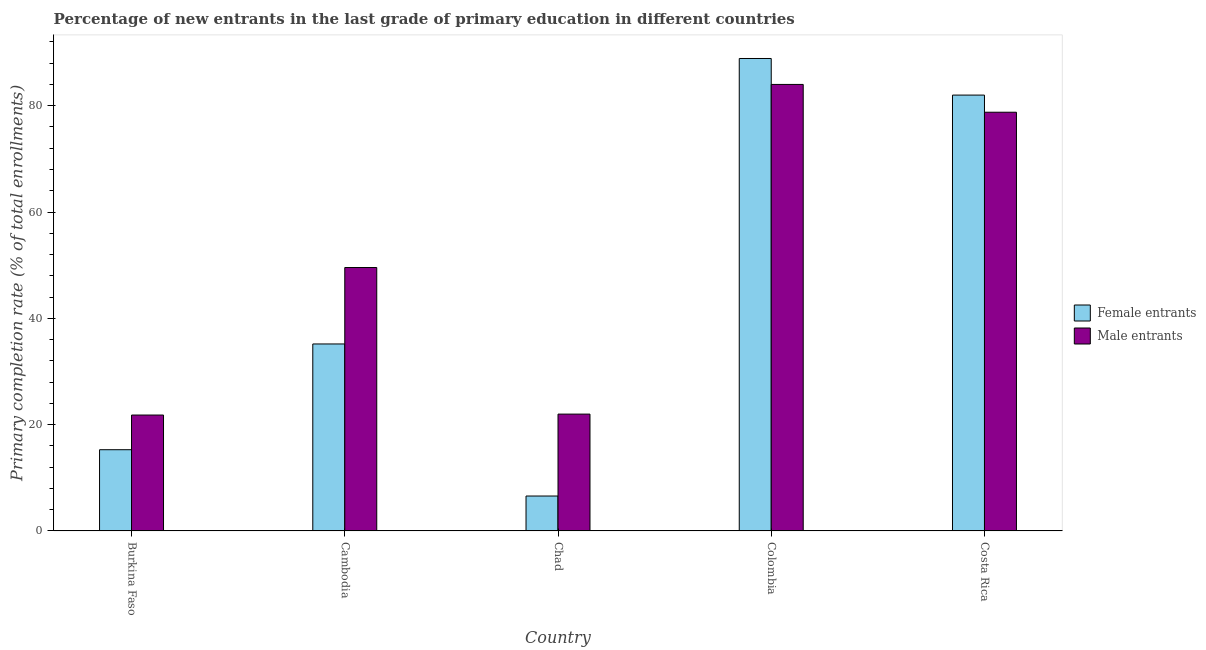How many different coloured bars are there?
Provide a short and direct response. 2. How many bars are there on the 2nd tick from the left?
Offer a terse response. 2. What is the label of the 3rd group of bars from the left?
Ensure brevity in your answer.  Chad. What is the primary completion rate of male entrants in Burkina Faso?
Keep it short and to the point. 21.8. Across all countries, what is the maximum primary completion rate of male entrants?
Offer a very short reply. 84. Across all countries, what is the minimum primary completion rate of female entrants?
Provide a succinct answer. 6.57. In which country was the primary completion rate of male entrants minimum?
Offer a terse response. Burkina Faso. What is the total primary completion rate of female entrants in the graph?
Your answer should be compact. 227.9. What is the difference between the primary completion rate of female entrants in Burkina Faso and that in Colombia?
Your answer should be very brief. -73.6. What is the difference between the primary completion rate of male entrants in Cambodia and the primary completion rate of female entrants in Chad?
Keep it short and to the point. 42.99. What is the average primary completion rate of female entrants per country?
Give a very brief answer. 45.58. What is the difference between the primary completion rate of male entrants and primary completion rate of female entrants in Costa Rica?
Provide a short and direct response. -3.22. What is the ratio of the primary completion rate of male entrants in Burkina Faso to that in Costa Rica?
Your answer should be very brief. 0.28. Is the difference between the primary completion rate of female entrants in Chad and Costa Rica greater than the difference between the primary completion rate of male entrants in Chad and Costa Rica?
Give a very brief answer. No. What is the difference between the highest and the second highest primary completion rate of female entrants?
Your response must be concise. 6.88. What is the difference between the highest and the lowest primary completion rate of female entrants?
Your response must be concise. 82.31. In how many countries, is the primary completion rate of male entrants greater than the average primary completion rate of male entrants taken over all countries?
Provide a short and direct response. 2. What does the 1st bar from the left in Colombia represents?
Make the answer very short. Female entrants. What does the 1st bar from the right in Chad represents?
Ensure brevity in your answer.  Male entrants. How many bars are there?
Make the answer very short. 10. How many countries are there in the graph?
Give a very brief answer. 5. Does the graph contain any zero values?
Provide a succinct answer. No. Where does the legend appear in the graph?
Ensure brevity in your answer.  Center right. How are the legend labels stacked?
Ensure brevity in your answer.  Vertical. What is the title of the graph?
Provide a succinct answer. Percentage of new entrants in the last grade of primary education in different countries. What is the label or title of the X-axis?
Ensure brevity in your answer.  Country. What is the label or title of the Y-axis?
Keep it short and to the point. Primary completion rate (% of total enrollments). What is the Primary completion rate (% of total enrollments) in Female entrants in Burkina Faso?
Make the answer very short. 15.28. What is the Primary completion rate (% of total enrollments) in Male entrants in Burkina Faso?
Your answer should be very brief. 21.8. What is the Primary completion rate (% of total enrollments) in Female entrants in Cambodia?
Your response must be concise. 35.18. What is the Primary completion rate (% of total enrollments) in Male entrants in Cambodia?
Make the answer very short. 49.56. What is the Primary completion rate (% of total enrollments) in Female entrants in Chad?
Keep it short and to the point. 6.57. What is the Primary completion rate (% of total enrollments) of Male entrants in Chad?
Your answer should be very brief. 21.98. What is the Primary completion rate (% of total enrollments) of Female entrants in Colombia?
Your answer should be compact. 88.88. What is the Primary completion rate (% of total enrollments) in Male entrants in Colombia?
Your response must be concise. 84. What is the Primary completion rate (% of total enrollments) of Female entrants in Costa Rica?
Ensure brevity in your answer.  82. What is the Primary completion rate (% of total enrollments) of Male entrants in Costa Rica?
Your answer should be very brief. 78.77. Across all countries, what is the maximum Primary completion rate (% of total enrollments) of Female entrants?
Offer a very short reply. 88.88. Across all countries, what is the maximum Primary completion rate (% of total enrollments) in Male entrants?
Provide a short and direct response. 84. Across all countries, what is the minimum Primary completion rate (% of total enrollments) in Female entrants?
Offer a very short reply. 6.57. Across all countries, what is the minimum Primary completion rate (% of total enrollments) of Male entrants?
Make the answer very short. 21.8. What is the total Primary completion rate (% of total enrollments) of Female entrants in the graph?
Ensure brevity in your answer.  227.9. What is the total Primary completion rate (% of total enrollments) of Male entrants in the graph?
Offer a terse response. 256.11. What is the difference between the Primary completion rate (% of total enrollments) in Female entrants in Burkina Faso and that in Cambodia?
Make the answer very short. -19.89. What is the difference between the Primary completion rate (% of total enrollments) in Male entrants in Burkina Faso and that in Cambodia?
Provide a short and direct response. -27.75. What is the difference between the Primary completion rate (% of total enrollments) of Female entrants in Burkina Faso and that in Chad?
Provide a short and direct response. 8.71. What is the difference between the Primary completion rate (% of total enrollments) of Male entrants in Burkina Faso and that in Chad?
Give a very brief answer. -0.18. What is the difference between the Primary completion rate (% of total enrollments) of Female entrants in Burkina Faso and that in Colombia?
Give a very brief answer. -73.6. What is the difference between the Primary completion rate (% of total enrollments) of Male entrants in Burkina Faso and that in Colombia?
Your answer should be compact. -62.2. What is the difference between the Primary completion rate (% of total enrollments) of Female entrants in Burkina Faso and that in Costa Rica?
Provide a short and direct response. -66.71. What is the difference between the Primary completion rate (% of total enrollments) of Male entrants in Burkina Faso and that in Costa Rica?
Give a very brief answer. -56.97. What is the difference between the Primary completion rate (% of total enrollments) in Female entrants in Cambodia and that in Chad?
Provide a succinct answer. 28.61. What is the difference between the Primary completion rate (% of total enrollments) in Male entrants in Cambodia and that in Chad?
Provide a short and direct response. 27.58. What is the difference between the Primary completion rate (% of total enrollments) of Female entrants in Cambodia and that in Colombia?
Your answer should be very brief. -53.7. What is the difference between the Primary completion rate (% of total enrollments) of Male entrants in Cambodia and that in Colombia?
Your answer should be very brief. -34.44. What is the difference between the Primary completion rate (% of total enrollments) in Female entrants in Cambodia and that in Costa Rica?
Make the answer very short. -46.82. What is the difference between the Primary completion rate (% of total enrollments) in Male entrants in Cambodia and that in Costa Rica?
Your response must be concise. -29.22. What is the difference between the Primary completion rate (% of total enrollments) in Female entrants in Chad and that in Colombia?
Make the answer very short. -82.31. What is the difference between the Primary completion rate (% of total enrollments) of Male entrants in Chad and that in Colombia?
Make the answer very short. -62.02. What is the difference between the Primary completion rate (% of total enrollments) in Female entrants in Chad and that in Costa Rica?
Provide a short and direct response. -75.43. What is the difference between the Primary completion rate (% of total enrollments) in Male entrants in Chad and that in Costa Rica?
Give a very brief answer. -56.79. What is the difference between the Primary completion rate (% of total enrollments) of Female entrants in Colombia and that in Costa Rica?
Keep it short and to the point. 6.88. What is the difference between the Primary completion rate (% of total enrollments) of Male entrants in Colombia and that in Costa Rica?
Offer a very short reply. 5.23. What is the difference between the Primary completion rate (% of total enrollments) in Female entrants in Burkina Faso and the Primary completion rate (% of total enrollments) in Male entrants in Cambodia?
Give a very brief answer. -34.27. What is the difference between the Primary completion rate (% of total enrollments) of Female entrants in Burkina Faso and the Primary completion rate (% of total enrollments) of Male entrants in Chad?
Your response must be concise. -6.7. What is the difference between the Primary completion rate (% of total enrollments) of Female entrants in Burkina Faso and the Primary completion rate (% of total enrollments) of Male entrants in Colombia?
Give a very brief answer. -68.72. What is the difference between the Primary completion rate (% of total enrollments) in Female entrants in Burkina Faso and the Primary completion rate (% of total enrollments) in Male entrants in Costa Rica?
Provide a succinct answer. -63.49. What is the difference between the Primary completion rate (% of total enrollments) of Female entrants in Cambodia and the Primary completion rate (% of total enrollments) of Male entrants in Chad?
Your answer should be very brief. 13.2. What is the difference between the Primary completion rate (% of total enrollments) in Female entrants in Cambodia and the Primary completion rate (% of total enrollments) in Male entrants in Colombia?
Make the answer very short. -48.82. What is the difference between the Primary completion rate (% of total enrollments) of Female entrants in Cambodia and the Primary completion rate (% of total enrollments) of Male entrants in Costa Rica?
Keep it short and to the point. -43.6. What is the difference between the Primary completion rate (% of total enrollments) of Female entrants in Chad and the Primary completion rate (% of total enrollments) of Male entrants in Colombia?
Provide a succinct answer. -77.43. What is the difference between the Primary completion rate (% of total enrollments) of Female entrants in Chad and the Primary completion rate (% of total enrollments) of Male entrants in Costa Rica?
Give a very brief answer. -72.2. What is the difference between the Primary completion rate (% of total enrollments) of Female entrants in Colombia and the Primary completion rate (% of total enrollments) of Male entrants in Costa Rica?
Your answer should be very brief. 10.11. What is the average Primary completion rate (% of total enrollments) of Female entrants per country?
Provide a succinct answer. 45.58. What is the average Primary completion rate (% of total enrollments) in Male entrants per country?
Your response must be concise. 51.22. What is the difference between the Primary completion rate (% of total enrollments) of Female entrants and Primary completion rate (% of total enrollments) of Male entrants in Burkina Faso?
Make the answer very short. -6.52. What is the difference between the Primary completion rate (% of total enrollments) in Female entrants and Primary completion rate (% of total enrollments) in Male entrants in Cambodia?
Offer a terse response. -14.38. What is the difference between the Primary completion rate (% of total enrollments) of Female entrants and Primary completion rate (% of total enrollments) of Male entrants in Chad?
Offer a terse response. -15.41. What is the difference between the Primary completion rate (% of total enrollments) in Female entrants and Primary completion rate (% of total enrollments) in Male entrants in Colombia?
Provide a short and direct response. 4.88. What is the difference between the Primary completion rate (% of total enrollments) of Female entrants and Primary completion rate (% of total enrollments) of Male entrants in Costa Rica?
Your response must be concise. 3.22. What is the ratio of the Primary completion rate (% of total enrollments) of Female entrants in Burkina Faso to that in Cambodia?
Ensure brevity in your answer.  0.43. What is the ratio of the Primary completion rate (% of total enrollments) in Male entrants in Burkina Faso to that in Cambodia?
Your answer should be compact. 0.44. What is the ratio of the Primary completion rate (% of total enrollments) of Female entrants in Burkina Faso to that in Chad?
Give a very brief answer. 2.33. What is the ratio of the Primary completion rate (% of total enrollments) in Male entrants in Burkina Faso to that in Chad?
Keep it short and to the point. 0.99. What is the ratio of the Primary completion rate (% of total enrollments) in Female entrants in Burkina Faso to that in Colombia?
Your answer should be compact. 0.17. What is the ratio of the Primary completion rate (% of total enrollments) in Male entrants in Burkina Faso to that in Colombia?
Your answer should be compact. 0.26. What is the ratio of the Primary completion rate (% of total enrollments) of Female entrants in Burkina Faso to that in Costa Rica?
Your answer should be very brief. 0.19. What is the ratio of the Primary completion rate (% of total enrollments) in Male entrants in Burkina Faso to that in Costa Rica?
Provide a short and direct response. 0.28. What is the ratio of the Primary completion rate (% of total enrollments) of Female entrants in Cambodia to that in Chad?
Offer a terse response. 5.36. What is the ratio of the Primary completion rate (% of total enrollments) of Male entrants in Cambodia to that in Chad?
Make the answer very short. 2.25. What is the ratio of the Primary completion rate (% of total enrollments) in Female entrants in Cambodia to that in Colombia?
Your answer should be very brief. 0.4. What is the ratio of the Primary completion rate (% of total enrollments) of Male entrants in Cambodia to that in Colombia?
Provide a succinct answer. 0.59. What is the ratio of the Primary completion rate (% of total enrollments) of Female entrants in Cambodia to that in Costa Rica?
Your response must be concise. 0.43. What is the ratio of the Primary completion rate (% of total enrollments) in Male entrants in Cambodia to that in Costa Rica?
Your answer should be very brief. 0.63. What is the ratio of the Primary completion rate (% of total enrollments) in Female entrants in Chad to that in Colombia?
Your answer should be compact. 0.07. What is the ratio of the Primary completion rate (% of total enrollments) of Male entrants in Chad to that in Colombia?
Keep it short and to the point. 0.26. What is the ratio of the Primary completion rate (% of total enrollments) of Female entrants in Chad to that in Costa Rica?
Offer a very short reply. 0.08. What is the ratio of the Primary completion rate (% of total enrollments) in Male entrants in Chad to that in Costa Rica?
Provide a succinct answer. 0.28. What is the ratio of the Primary completion rate (% of total enrollments) of Female entrants in Colombia to that in Costa Rica?
Provide a short and direct response. 1.08. What is the ratio of the Primary completion rate (% of total enrollments) in Male entrants in Colombia to that in Costa Rica?
Give a very brief answer. 1.07. What is the difference between the highest and the second highest Primary completion rate (% of total enrollments) of Female entrants?
Make the answer very short. 6.88. What is the difference between the highest and the second highest Primary completion rate (% of total enrollments) in Male entrants?
Provide a succinct answer. 5.23. What is the difference between the highest and the lowest Primary completion rate (% of total enrollments) of Female entrants?
Keep it short and to the point. 82.31. What is the difference between the highest and the lowest Primary completion rate (% of total enrollments) in Male entrants?
Keep it short and to the point. 62.2. 